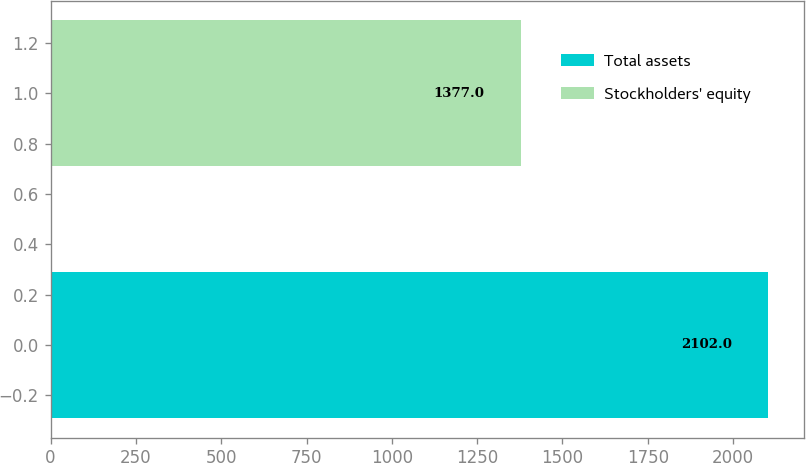<chart> <loc_0><loc_0><loc_500><loc_500><bar_chart><fcel>Total assets<fcel>Stockholders' equity<nl><fcel>2102<fcel>1377<nl></chart> 